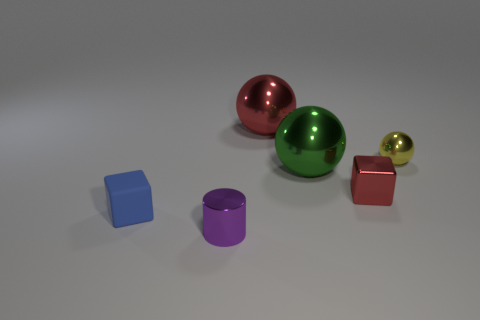Describe the lighting and shadows in the scene. The lighting in the image appears to be soft and diffused, coming from the upper left direction, judging by the gently cast shadows to the right of the objects. The shadows are subtle and elongated, suggesting an ambient light source. 